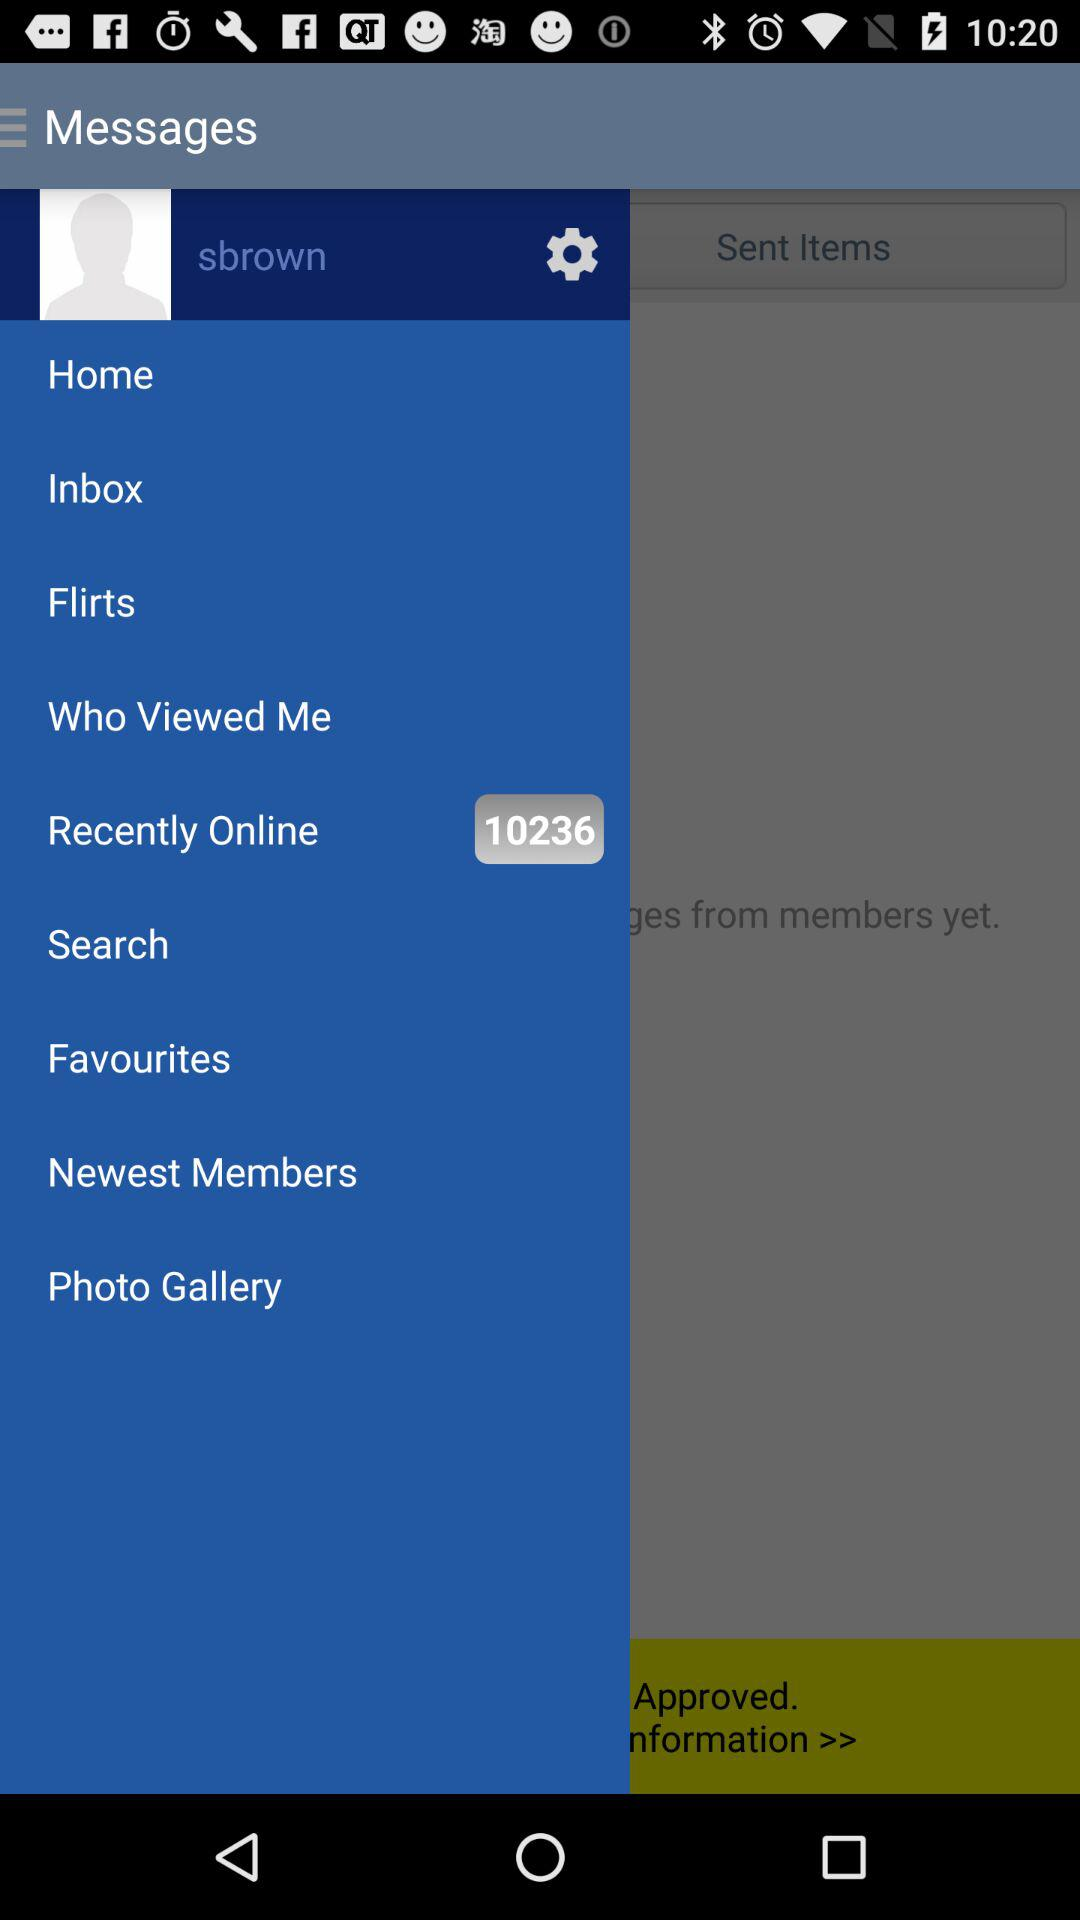How many items have been sent?
Answer the question using a single word or phrase. 0 